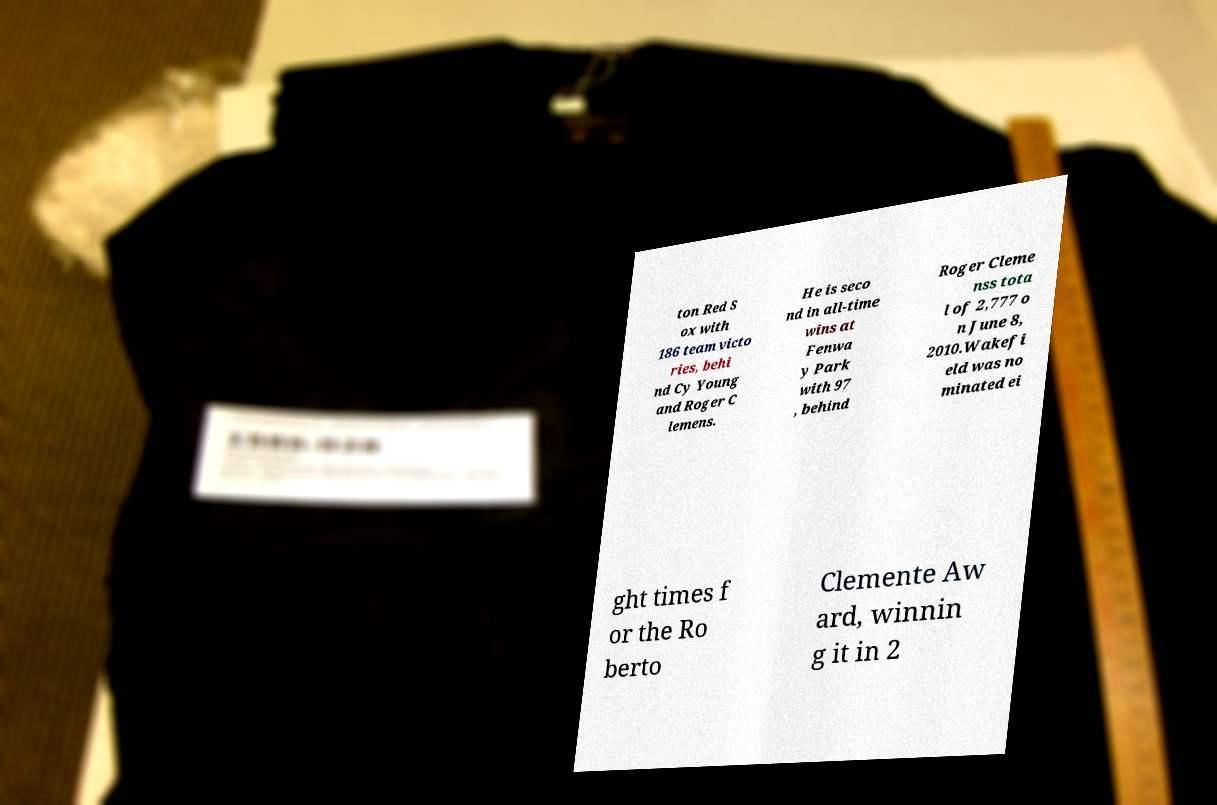Can you read and provide the text displayed in the image?This photo seems to have some interesting text. Can you extract and type it out for me? ton Red S ox with 186 team victo ries, behi nd Cy Young and Roger C lemens. He is seco nd in all-time wins at Fenwa y Park with 97 , behind Roger Cleme nss tota l of 2,777 o n June 8, 2010.Wakefi eld was no minated ei ght times f or the Ro berto Clemente Aw ard, winnin g it in 2 